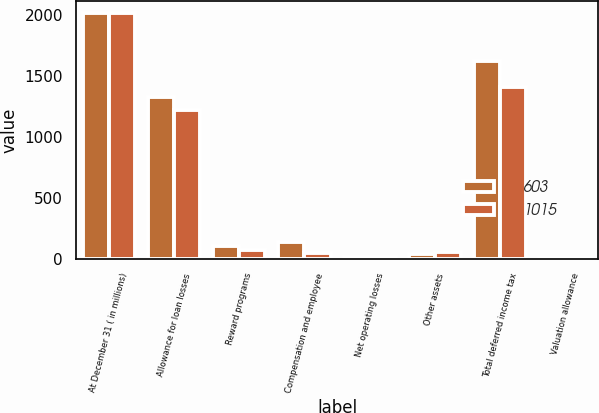<chart> <loc_0><loc_0><loc_500><loc_500><stacked_bar_chart><ecel><fcel>At December 31 ( in millions)<fcel>Allowance for loan losses<fcel>Reward programs<fcel>Compensation and employee<fcel>Net operating losses<fcel>Other assets<fcel>Total deferred income tax<fcel>Valuation allowance<nl><fcel>603<fcel>2015<fcel>1329<fcel>106<fcel>135<fcel>12<fcel>38<fcel>1620<fcel>9<nl><fcel>1015<fcel>2014<fcel>1221<fcel>72<fcel>45<fcel>12<fcel>56<fcel>1406<fcel>10<nl></chart> 